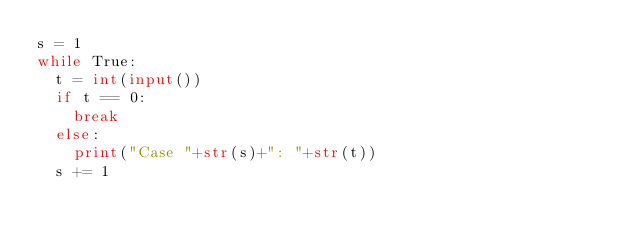Convert code to text. <code><loc_0><loc_0><loc_500><loc_500><_Python_>s = 1
while True:
	t = int(input())
	if t == 0:
		break
	else:
		print("Case "+str(s)+": "+str(t))
	s += 1</code> 